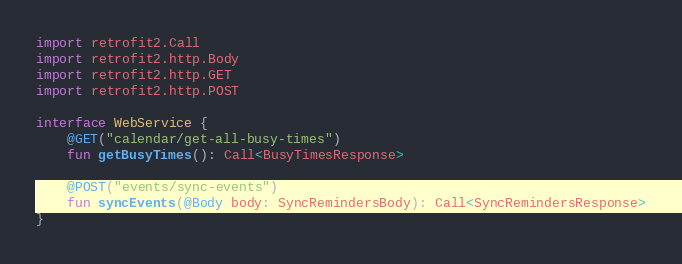Convert code to text. <code><loc_0><loc_0><loc_500><loc_500><_Kotlin_>import retrofit2.Call
import retrofit2.http.Body
import retrofit2.http.GET
import retrofit2.http.POST

interface WebService {
    @GET("calendar/get-all-busy-times")
    fun getBusyTimes(): Call<BusyTimesResponse>

    @POST("events/sync-events")
    fun syncEvents(@Body body: SyncRemindersBody): Call<SyncRemindersResponse>
}</code> 